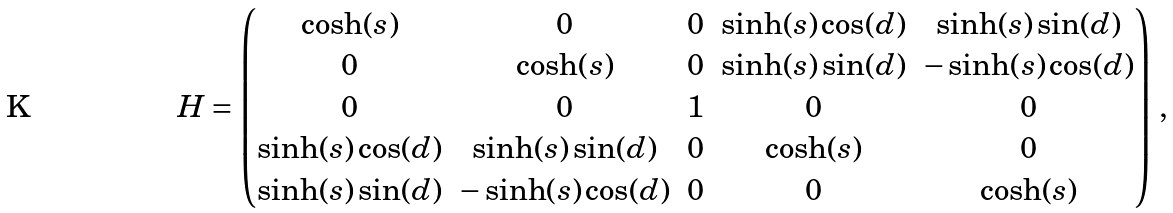<formula> <loc_0><loc_0><loc_500><loc_500>H = \begin{pmatrix} \cosh ( s ) & 0 & 0 & \sinh ( s ) \cos ( d ) & \sinh ( s ) \sin ( d ) \\ 0 & \cosh ( s ) & 0 & \sinh ( s ) \sin ( d ) & - \sinh ( s ) \cos ( d ) \\ 0 & 0 & 1 & 0 & 0 \\ \sinh ( s ) \cos ( d ) & \sinh ( s ) \sin ( d ) & 0 & \cosh ( s ) & 0 \\ \sinh ( s ) \sin ( d ) & - \sinh ( s ) \cos ( d ) & 0 & 0 & \cosh ( s ) \end{pmatrix} \, ,</formula> 